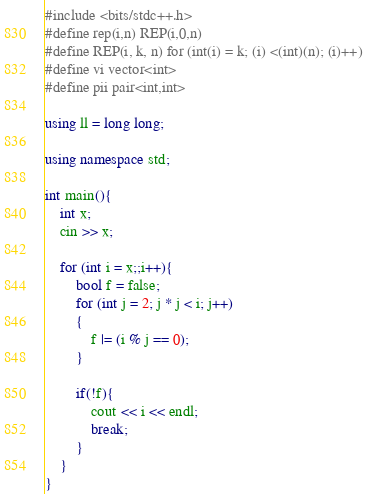<code> <loc_0><loc_0><loc_500><loc_500><_C++_>#include <bits/stdc++.h>
#define rep(i,n) REP(i,0,n)
#define REP(i, k, n) for (int(i) = k; (i) <(int)(n); (i)++)
#define vi vector<int>
#define pii pair<int,int>

using ll = long long;

using namespace std;

int main(){
    int x;
    cin >> x;

    for (int i = x;;i++){
        bool f = false;
        for (int j = 2; j * j < i; j++)
        {
            f |= (i % j == 0);
        }

        if(!f){
            cout << i << endl;
            break;
        }
    }
}</code> 